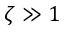<formula> <loc_0><loc_0><loc_500><loc_500>\zeta \gg 1</formula> 